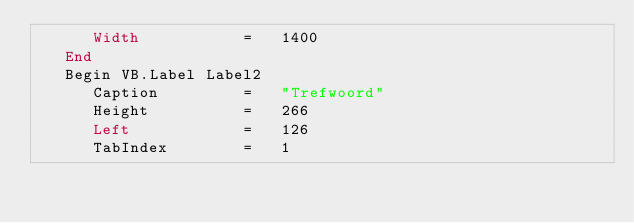<code> <loc_0><loc_0><loc_500><loc_500><_VisualBasic_>      Width           =   1400
   End
   Begin VB.Label Label2 
      Caption         =   "Trefwoord"
      Height          =   266
      Left            =   126
      TabIndex        =   1</code> 